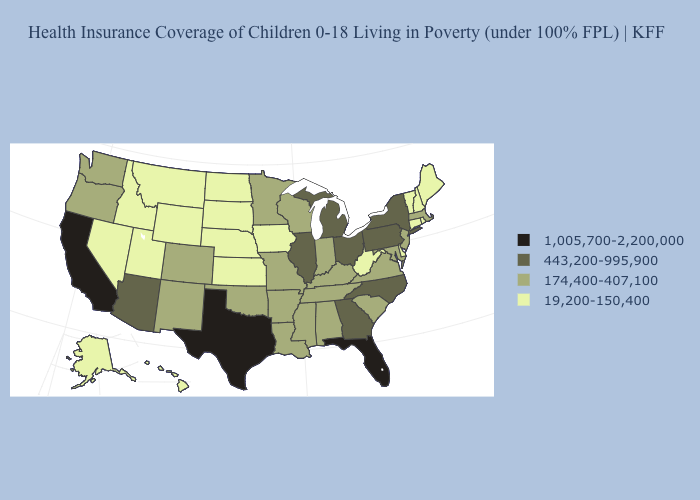Among the states that border Rhode Island , which have the lowest value?
Write a very short answer. Connecticut. Does North Dakota have the lowest value in the MidWest?
Be succinct. Yes. Among the states that border Louisiana , does Texas have the lowest value?
Give a very brief answer. No. Does South Dakota have the highest value in the USA?
Short answer required. No. Does Wyoming have the lowest value in the USA?
Keep it brief. Yes. Name the states that have a value in the range 174,400-407,100?
Give a very brief answer. Alabama, Arkansas, Colorado, Indiana, Kentucky, Louisiana, Maryland, Massachusetts, Minnesota, Mississippi, Missouri, New Jersey, New Mexico, Oklahoma, Oregon, South Carolina, Tennessee, Virginia, Washington, Wisconsin. What is the value of Pennsylvania?
Quick response, please. 443,200-995,900. Which states have the highest value in the USA?
Give a very brief answer. California, Florida, Texas. Does Maine have a lower value than Kansas?
Answer briefly. No. How many symbols are there in the legend?
Give a very brief answer. 4. What is the value of Virginia?
Answer briefly. 174,400-407,100. What is the value of Nevada?
Quick response, please. 19,200-150,400. Name the states that have a value in the range 1,005,700-2,200,000?
Short answer required. California, Florida, Texas. Name the states that have a value in the range 174,400-407,100?
Quick response, please. Alabama, Arkansas, Colorado, Indiana, Kentucky, Louisiana, Maryland, Massachusetts, Minnesota, Mississippi, Missouri, New Jersey, New Mexico, Oklahoma, Oregon, South Carolina, Tennessee, Virginia, Washington, Wisconsin. 